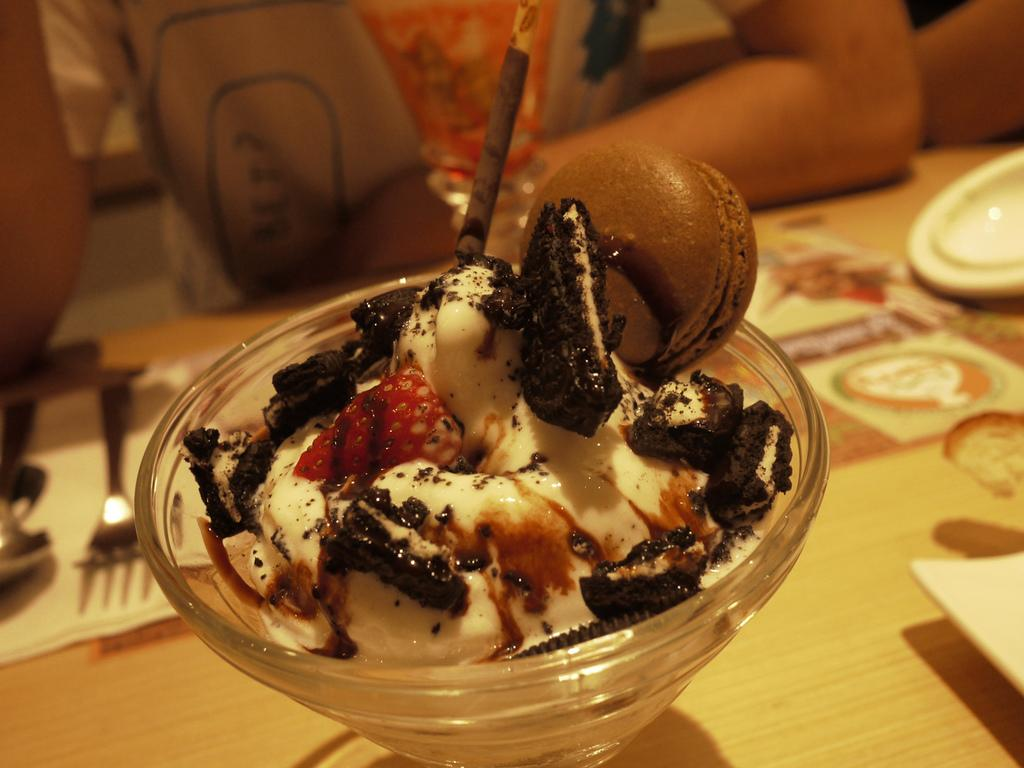What type of container is holding the ice cream in the image? There is an ice cream in a glass bowl in the image. Where is the ice cream placed? The ice cream is kept on a table. What can be used for wiping or blowing one's nose in the image? There is tissue present in the image. What utensils are visible in the image? There is a spoon and a fork in the image. Can you describe the people in the image? People are sitting behind the table in the image. What scientific experiment is being conducted on the ice cream in the image? There is no scientific experiment being conducted on the ice cream in the image; it is simply a bowl of ice cream on a table. How many legs can be seen on the people in the image? The people in the image are not visible in the image, so it is impossible to determine the number of legs. 